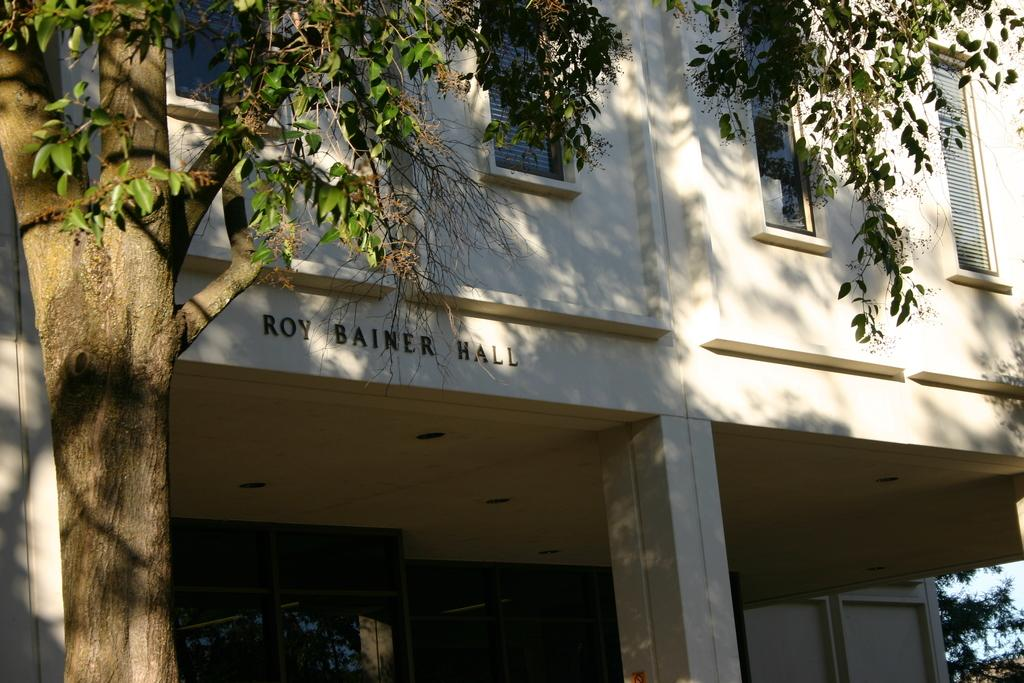What type of structure is visible in the image? There is a building with windows in the image. What other natural elements can be seen in the image? There are trees in the image. What part of the sky is visible in the image? The sky is partially visible in the image. What is the texture of the voice in the image? There is no voice present in the image, so it is not possible to determine its texture. 